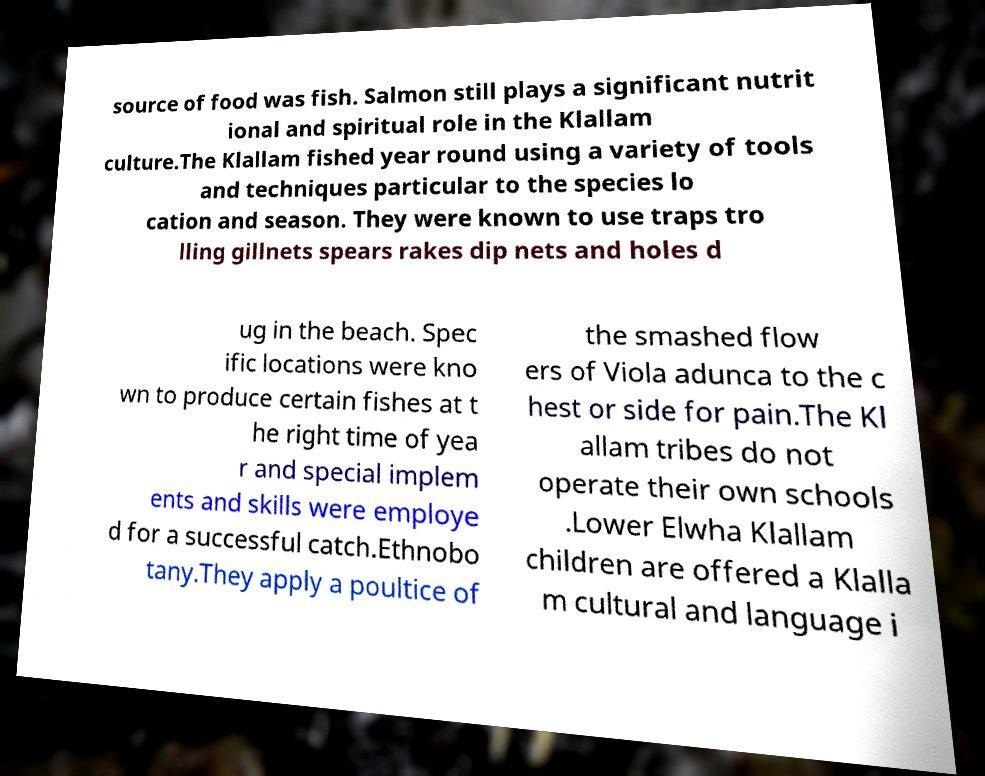Please identify and transcribe the text found in this image. source of food was fish. Salmon still plays a significant nutrit ional and spiritual role in the Klallam culture.The Klallam fished year round using a variety of tools and techniques particular to the species lo cation and season. They were known to use traps tro lling gillnets spears rakes dip nets and holes d ug in the beach. Spec ific locations were kno wn to produce certain fishes at t he right time of yea r and special implem ents and skills were employe d for a successful catch.Ethnobo tany.They apply a poultice of the smashed flow ers of Viola adunca to the c hest or side for pain.The Kl allam tribes do not operate their own schools .Lower Elwha Klallam children are offered a Klalla m cultural and language i 